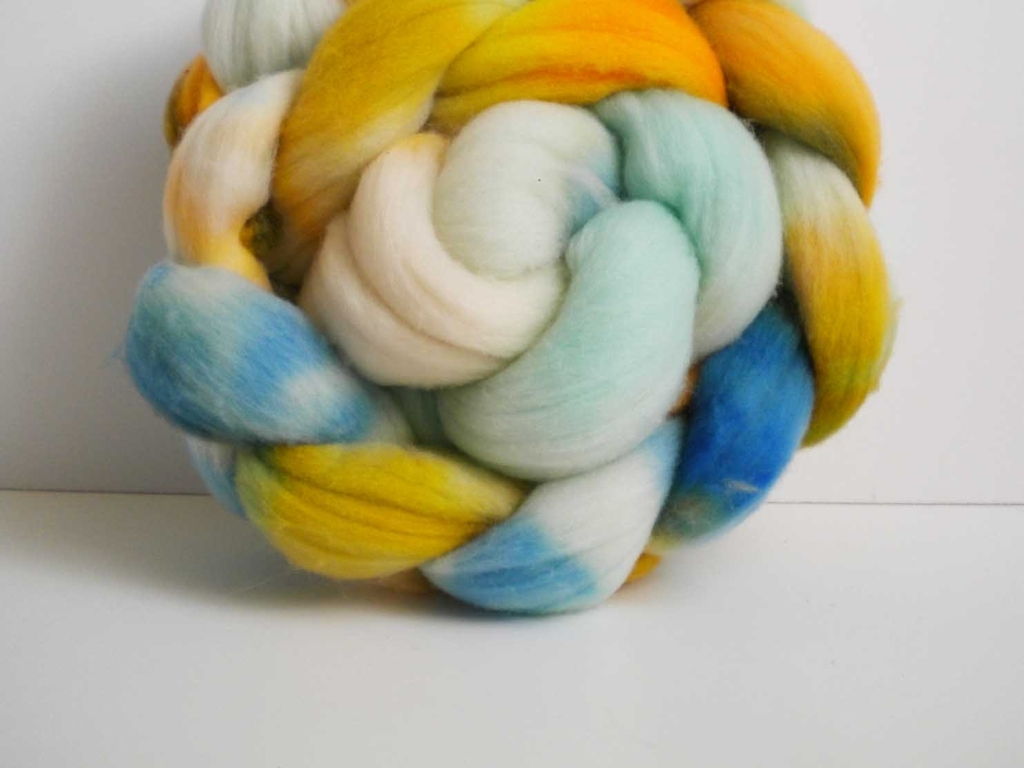Could you elaborate on the textures and colors visible in this image? In the image, the wool roving features a soft and fluffy texture that suggests its cozy and warm nature. The colors are a vibrant mix of yellows, blues, and hints of green, reminiscent of spring meadows under a sunny sky, suggesting it could be hand-dyed for a unique look. 